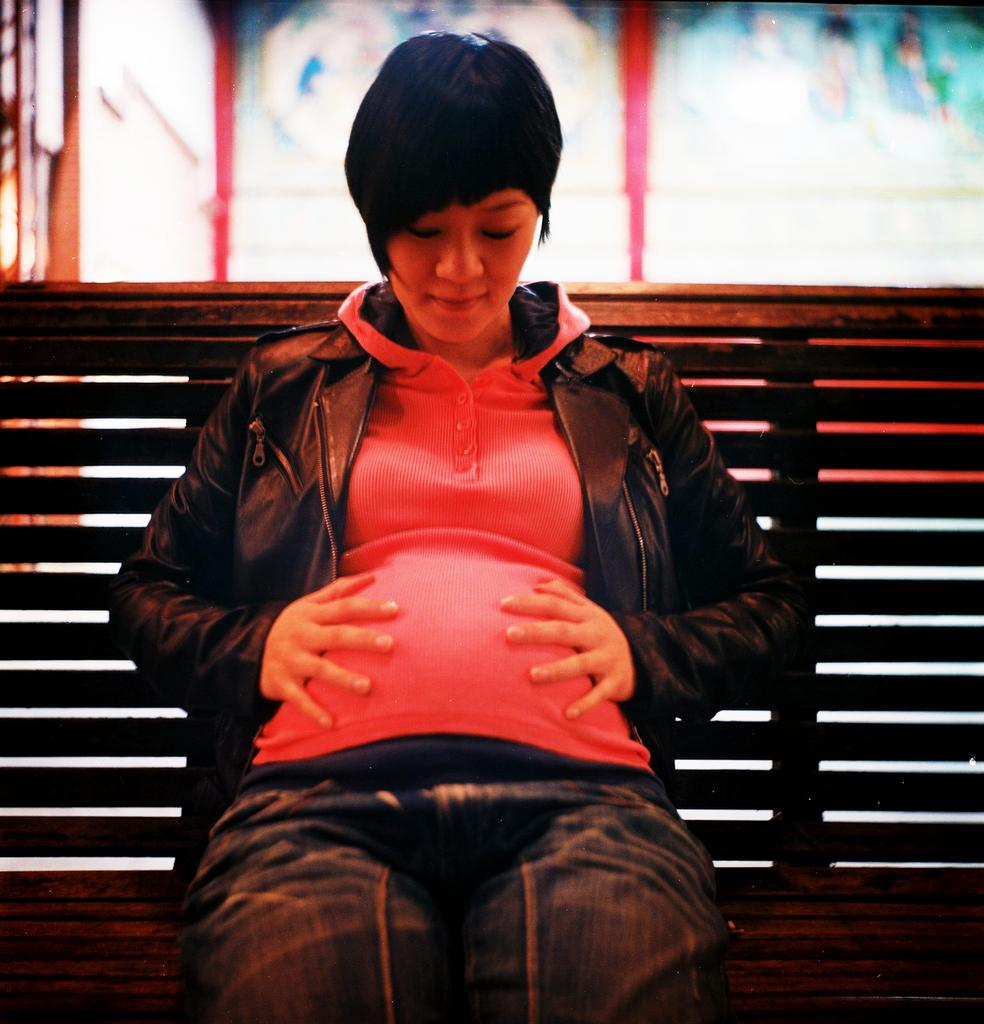Who is the main subject in the image? There is a woman in the image. What is the woman doing in the image? The woman is sitting on a bench. What type of ring is the scarecrow wearing on its finger in the image? There is no scarecrow or ring present in the image; it only features a woman sitting on a bench. 